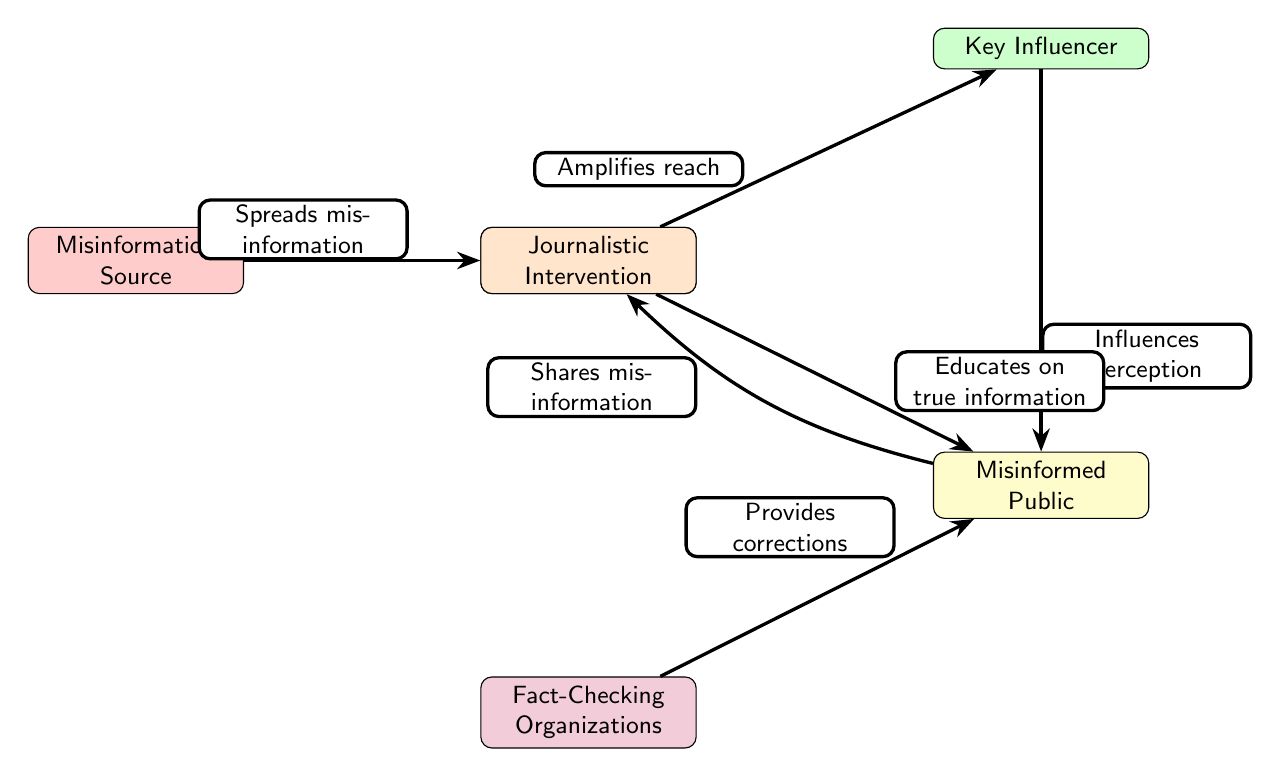What are the main nodes in the diagram? The main nodes in the diagram are Misinformation Source, Social Media Platforms, Key Influencer, Misinformed Public, Fact-Checking Organizations, and Journalistic Intervention.
Answer: Misinformation Source, Social Media Platforms, Key Influencer, Misinformed Public, Fact-Checking Organizations, Journalistic Intervention How many edges does the diagram have? The diagram has five edges, indicating the flow of information and relationships between the nodes.
Answer: 5 Which node is connected to the Misinformed Public? The Misinformed Public is directly connected to the Key Influencer, Social Media Platforms, Fact-Checking Organizations, and Journalistic Intervention.
Answer: Key Influencer, Social Media Platforms, Fact-Checking Organizations, Journalistic Intervention What is the primary role of Social Media Platforms in the diagram? The primary role of Social Media Platforms is to amplify the reach of misinformation originating from the Misinformation Source.
Answer: Amplifies reach How does Misinformed Public interact with Social Media Platforms? The Misinformed Public shares misinformation back to Social Media Platforms, creating a feedback loop that perpetuates misinformation.
Answer: Shares misinformation What do Fact-Checking Organizations provide to the Misinformed Public? Fact-Checking Organizations provide corrections to the Misinformed Public, helping them distinguish true information from misinformation.
Answer: Provides corrections What type of influence does Key Influencer have on the Misinformed Public? The Key Influencer influences the perception of the Misinformed Public by shaping their understanding of the misinformation.
Answer: Influences perception In what way does Journalistic Intervention assist the Misinformed Public? Journalistic Intervention educates the Misinformed Public on true information, aiming to counter the effects of misinformation.
Answer: Educates on true information Which edge indicates the direction of misinformation spread? The edge from Misinformation Source to Social Media Platforms indicates the initial spread of misinformation.
Answer: Spreads misinformation 